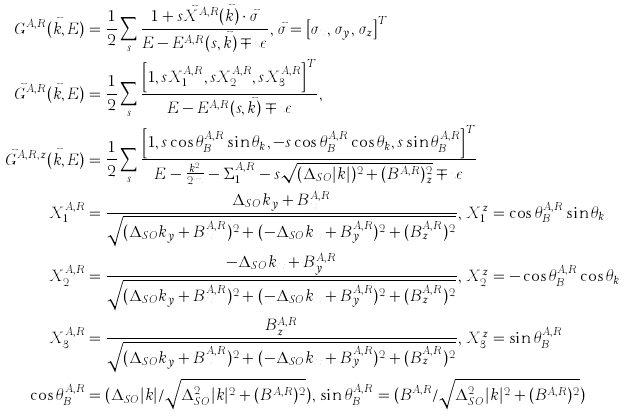Convert formula to latex. <formula><loc_0><loc_0><loc_500><loc_500>G ^ { A , R } ( \vec { k } , E ) & = \frac { 1 } { 2 } \sum _ { s } \frac { 1 + s \vec { X } ^ { A , R } ( \vec { k } ) \cdot \vec { \sigma } } { E - E ^ { A , R } ( s , \vec { k } ) \mp \imath \epsilon } , \, \vec { \sigma } = \left [ \sigma _ { x } , \, \sigma _ { y } , \, \sigma _ { z } \right ] ^ { T } \\ \vec { G } ^ { A , R } ( \vec { k } , E ) & = \frac { 1 } { 2 } \sum _ { s } \frac { \left [ 1 , s X _ { 1 } ^ { A , R } , s X _ { 2 } ^ { A , R } , s X _ { 3 } ^ { A , R } \right ] ^ { T } } { E - E ^ { A , R } ( s , \vec { k } ) \mp \imath \epsilon } , \\ \vec { G } ^ { A , R , z } ( \vec { k } , E ) & = \frac { 1 } { 2 } \sum _ { s } \frac { \left [ 1 , s \cos \theta ^ { A , R } _ { B } \sin \theta _ { k } , - s \cos \theta ^ { A , R } _ { B } \cos \theta _ { k } , s \sin \theta ^ { A , R } _ { B } \right ] ^ { T } } { E - \frac { k ^ { 2 } } { 2 m } - \Sigma _ { 1 } ^ { A , R } - s \sqrt { ( \Delta _ { S O } | k | ) ^ { 2 } + ( B ^ { A , R } ) _ { z } ^ { 2 } } \mp \imath \epsilon } \\ X _ { 1 } ^ { A , R } & = \frac { \Delta _ { S O } k _ { y } + B _ { x } ^ { A , R } } { \sqrt { ( \Delta _ { S O } k _ { y } + B _ { x } ^ { A , R } ) ^ { 2 } + ( - \Delta _ { S O } k _ { x } + B _ { y } ^ { A , R } ) ^ { 2 } + ( B _ { z } ^ { A , R } ) ^ { 2 } } } , \, X _ { 1 } ^ { z } = \cos \theta ^ { A , R } _ { B } \sin \theta _ { k } \\ X _ { 2 } ^ { A , R } & = \frac { - \Delta _ { S O } k _ { x } + B _ { y } ^ { A , R } } { \sqrt { ( \Delta _ { S O } k _ { y } + B _ { x } ^ { A , R } ) ^ { 2 } + ( - \Delta _ { S O } k _ { x } + B _ { y } ^ { A , R } ) ^ { 2 } + ( B _ { z } ^ { A , R } ) ^ { 2 } } } , \, X _ { 2 } ^ { z } = - \cos \theta ^ { A , R } _ { B } \cos \theta _ { k } \\ X _ { 3 } ^ { A , R } & = \frac { B _ { z } ^ { A , R } } { \sqrt { ( \Delta _ { S O } k _ { y } + B _ { x } ^ { A , R } ) ^ { 2 } + ( - \Delta _ { S O } k _ { x } + B _ { y } ^ { A , R } ) ^ { 2 } + ( B _ { z } ^ { A , R } ) ^ { 2 } } } , \, X _ { 3 } ^ { z } = \sin \theta _ { B } ^ { A , R } \\ \cos \theta _ { B } ^ { A , R } & = ( \Delta _ { S O } | k | / \sqrt { \Delta _ { S O } ^ { 2 } | k | ^ { 2 } + ( B ^ { A , R } ) ^ { 2 } } ) , \, \sin \theta _ { B } ^ { A , R } = ( B ^ { A , R } / \sqrt { \Delta _ { S O } ^ { 2 } | k | ^ { 2 } + ( B ^ { A , R } ) ^ { 2 } } )</formula> 